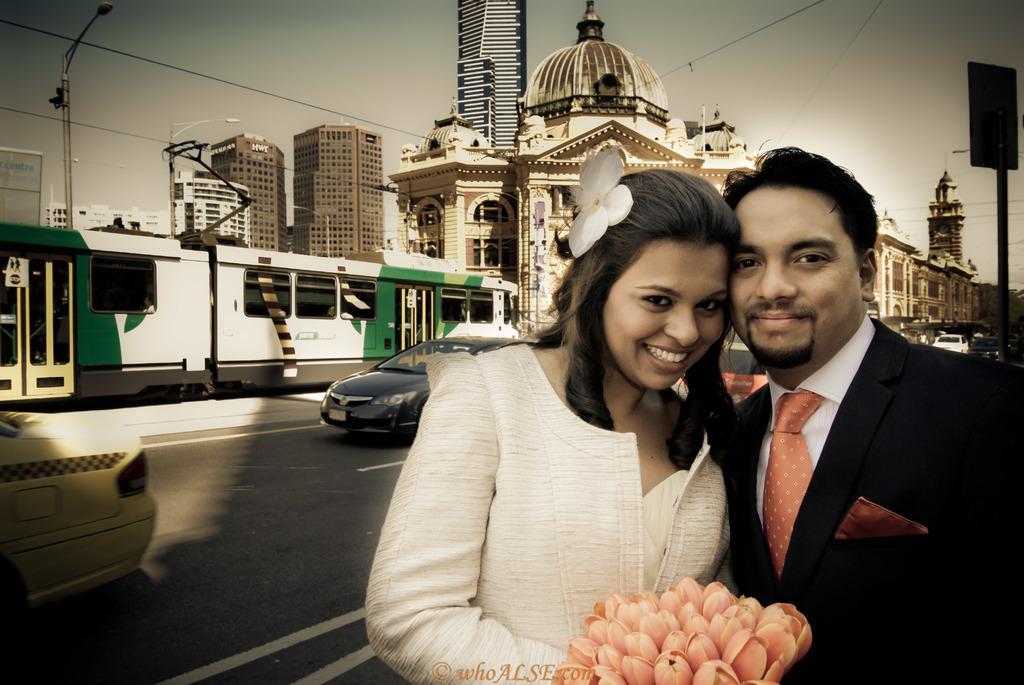In one or two sentences, can you explain what this image depicts? On the right side of the image, we can see a man in a suit and woman in white dress. They both are watching and smiling. Here we can see flowers and watermark. Background we can see few buildings, vehicles, road, poles, wires, board and sky. 